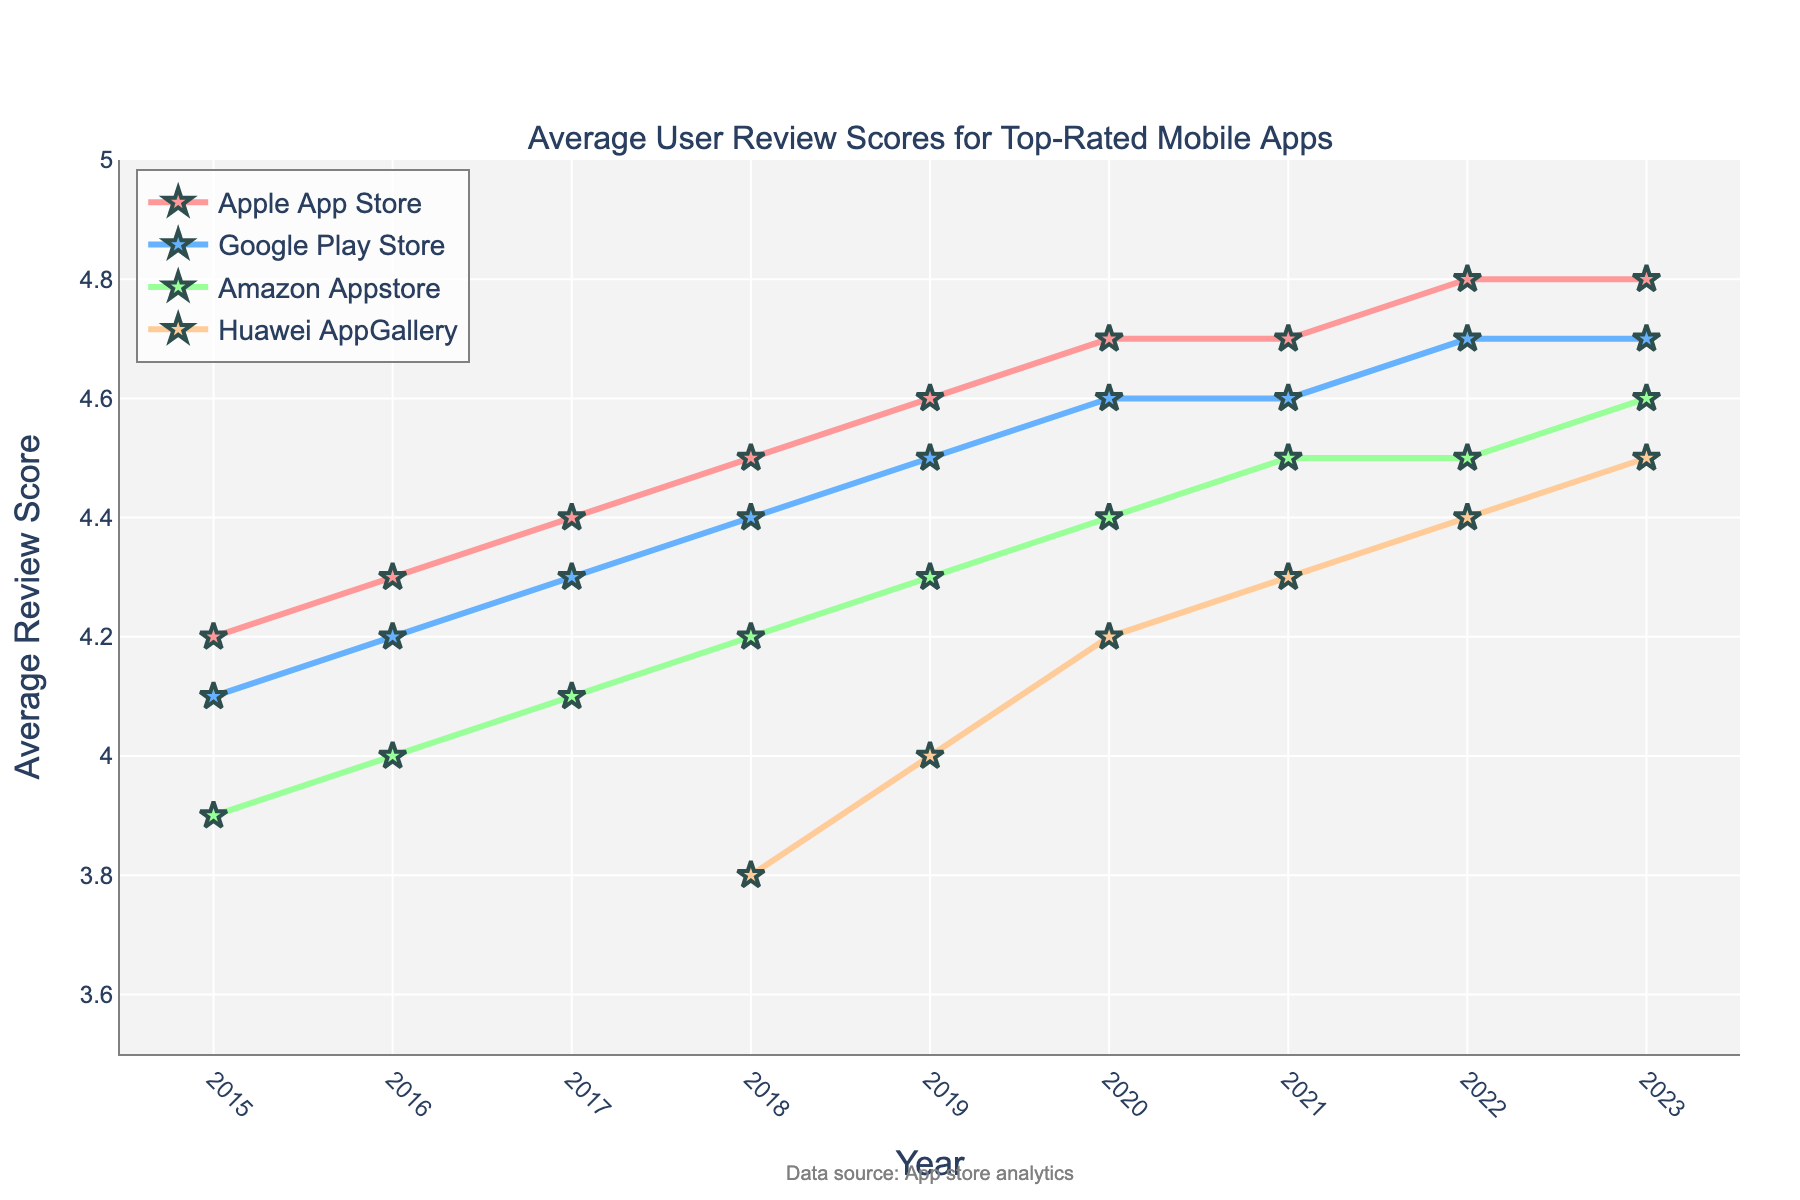Which year has the highest average review score for the Apple App Store? Observe the values for the Apple App Store. The highest value is 4.8, which occurred in both 2022 and 2023.
Answer: 2022 and 2023 How did the average review score for the Huawei AppGallery change from 2018 to 2023? Compare the review scores for the Huawei AppGallery from 2018 (3.8) to 2023 (4.5). It increased by 0.7 points.
Answer: Increased by 0.7 Which app store had the lowest average review score in 2015? Observe the values for each app store in 2015. The Amazon Appstore has the lowest score of 3.9.
Answer: Amazon Appstore What is the difference in average review scores between the Google Play Store and the Amazon Appstore in 2023? Subtract the Amazon Appstore score (4.6) from the Google Play Store score (4.7).
Answer: 0.1 Which app store showed a consistent increase in average review scores every year from 2015 to 2023? Check the trend of average review scores year by year for each app store. The Apple App Store shows a consistent increase.
Answer: Apple App Store By how much did the average review score for the Google Play Store increase from 2015 to 2023? Subtract the 2015 score (4.1) from the 2023 score (4.7).
Answer: 0.6 Which app store had the most significant increase in average review scores from their initial year to 2023? Compare the difference between the initial and 2023 scores for each app store. The Huawei AppGallery increased the most (from 3.8 in 2018 to 4.5 in 2023).
Answer: Huawei AppGallery What is the average review score of the Apple App Store over the years 2015 to 2023? Calculate the average by summing Apple App Store scores (4.2+4.3+4.4+4.5+4.6+4.7+4.7+4.8+4.8) and dividing by the number of years (9). The sum is 40.0, so the average is 40.0/9 ≈ 4.44
Answer: 4.44 Which app stores had the same average review score in the most recent year, 2023? Compare the 2023 scores. The Apple App Store and Google Play Store both have 4.7.
Answer: Apple App Store and Google Play Store How does the best year for user reviews in the Google Play Store compare with the best year in Huawei AppGallery? The best year for Google Play Store (2023, 4.7) is higher compared to Huawei AppGallery's best year (2023, 4.5).
Answer: Google Play Store scores higher 